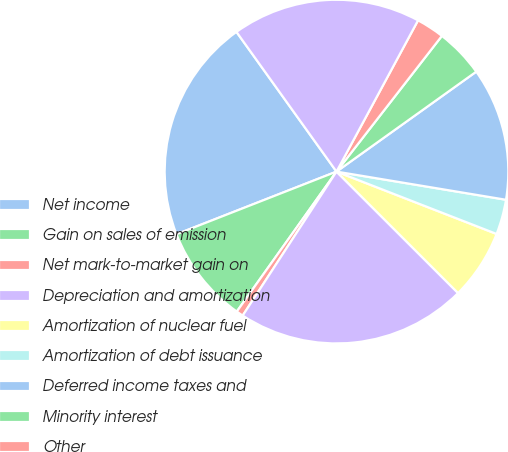Convert chart. <chart><loc_0><loc_0><loc_500><loc_500><pie_chart><fcel>Net income<fcel>Gain on sales of emission<fcel>Net mark-to-market gain on<fcel>Depreciation and amortization<fcel>Amortization of nuclear fuel<fcel>Amortization of debt issuance<fcel>Deferred income taxes and<fcel>Minority interest<fcel>Other<fcel>Receivables<nl><fcel>21.05%<fcel>9.21%<fcel>0.66%<fcel>21.7%<fcel>6.58%<fcel>3.29%<fcel>12.5%<fcel>4.61%<fcel>2.64%<fcel>17.76%<nl></chart> 